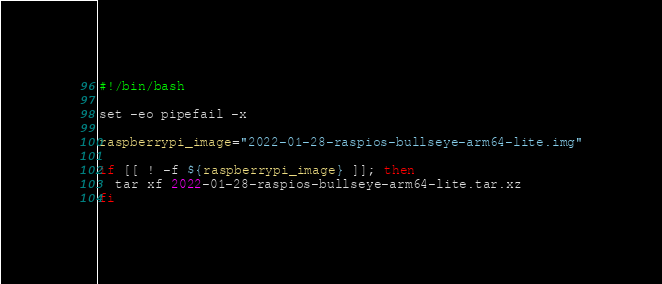<code> <loc_0><loc_0><loc_500><loc_500><_Bash_>#!/bin/bash

set -eo pipefail -x

raspberrypi_image="2022-01-28-raspios-bullseye-arm64-lite.img"

if [[ ! -f ${raspberrypi_image} ]]; then
  tar xf 2022-01-28-raspios-bullseye-arm64-lite.tar.xz
fi
</code> 